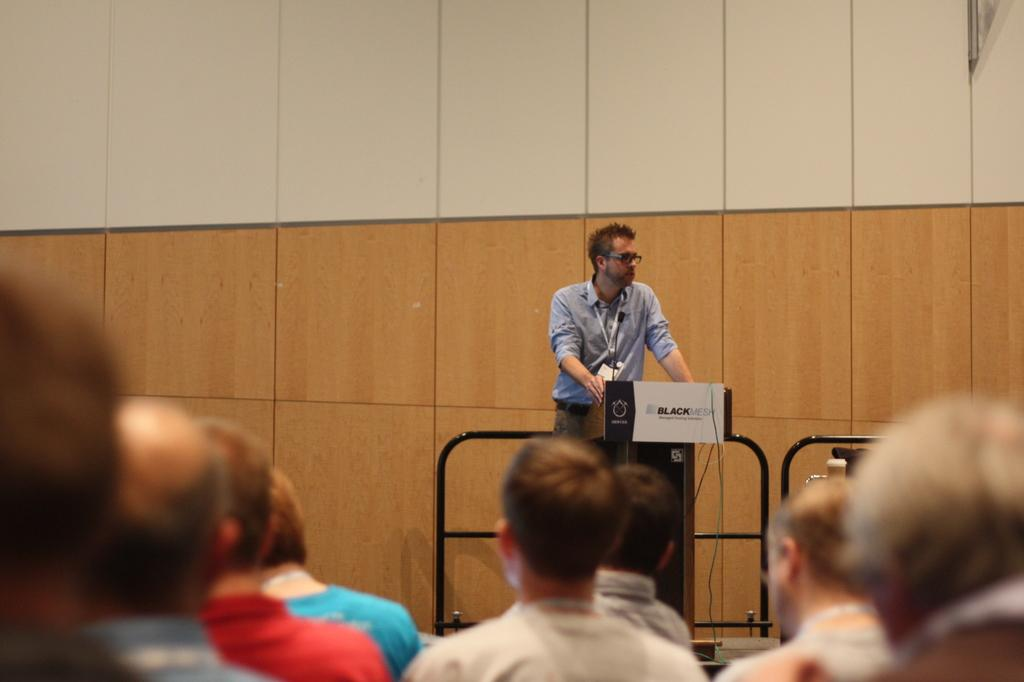What is happening with the group of persons in the image? There is a group of persons sitting at the bottom of the image. What is the standing person doing in the image? There is one person standing in the middle of the image, and they are holding an object. What can be seen in the background of the image? There is a wall in the background of the image. How does the wall in the image prevent the group of persons from moving? The wall in the image does not prevent the group of persons from moving; it is just a background element. What type of shock can be seen affecting the standing person in the image? There is no shock present in the image; the standing person is simply holding an object. 